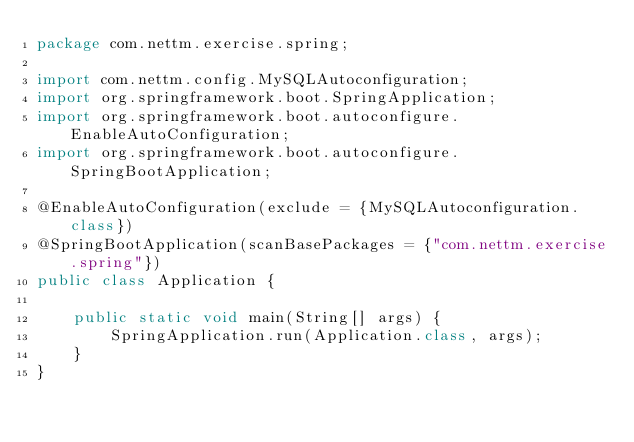<code> <loc_0><loc_0><loc_500><loc_500><_Java_>package com.nettm.exercise.spring;

import com.nettm.config.MySQLAutoconfiguration;
import org.springframework.boot.SpringApplication;
import org.springframework.boot.autoconfigure.EnableAutoConfiguration;
import org.springframework.boot.autoconfigure.SpringBootApplication;

@EnableAutoConfiguration(exclude = {MySQLAutoconfiguration.class})
@SpringBootApplication(scanBasePackages = {"com.nettm.exercise.spring"})
public class Application {

    public static void main(String[] args) {
        SpringApplication.run(Application.class, args);
    }
}
</code> 